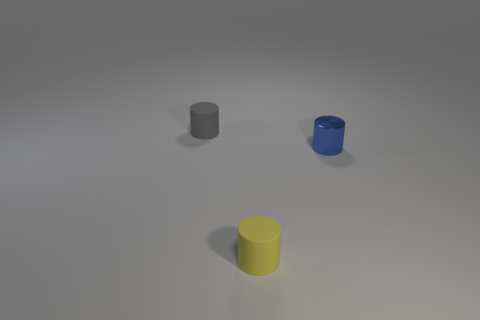What number of other things are there of the same shape as the small blue metallic object?
Your response must be concise. 2. What number of blocks are either big blue rubber objects or blue metallic things?
Make the answer very short. 0. There is a matte thing right of the rubber cylinder behind the shiny object; is there a cylinder that is right of it?
Provide a short and direct response. Yes. There is another rubber thing that is the same shape as the yellow object; what is its color?
Make the answer very short. Gray. How many purple objects are either metal objects or small matte objects?
Provide a short and direct response. 0. What is the tiny blue object on the right side of the gray matte thing that is behind the blue metal cylinder made of?
Provide a succinct answer. Metal. Is the shape of the small blue metal thing the same as the yellow rubber object?
Keep it short and to the point. Yes. There is another metal object that is the same size as the gray thing; what is its color?
Your answer should be very brief. Blue. Are there any blue metal cylinders?
Provide a short and direct response. Yes. Is the cylinder that is to the left of the tiny yellow rubber cylinder made of the same material as the yellow object?
Keep it short and to the point. Yes. 